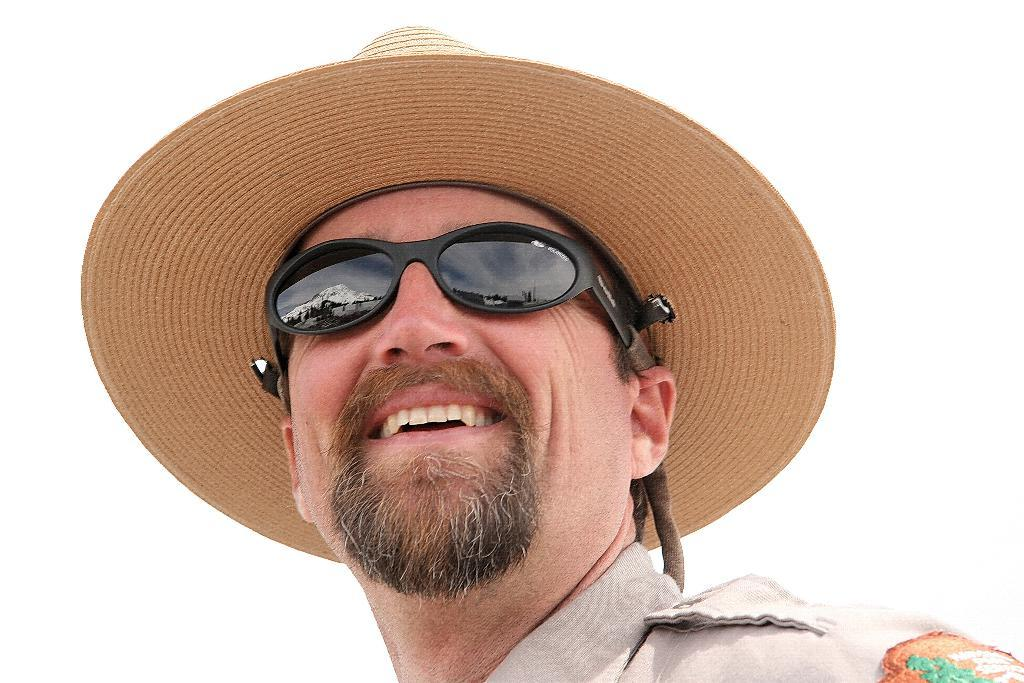Who is present in the image? There is a man in the picture. What is the man's facial expression? The man is smiling. What accessories is the man wearing? The man is wearing a cap and sunglasses. What is the color of the background in the image? The background of the image is white. Can you see a snake slithering in the background of the image? There is no snake present in the image; the background is white. 